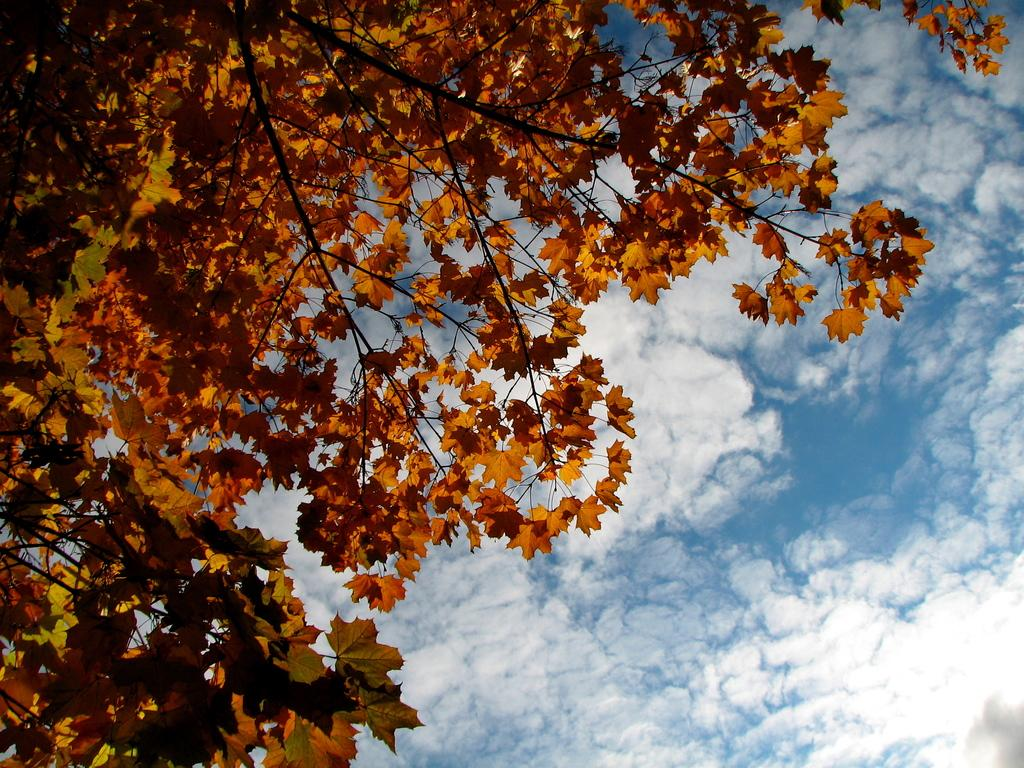What type of plant can be seen in the image? There is a tree in the image. What part of the natural environment is visible in the image? The sky is visible in the image. What country is the tree from in the image? The country of origin for the tree is not mentioned or visible in the image. What type of request is being made by the tree in the image? Trees do not make requests, as they are inanimate objects. 